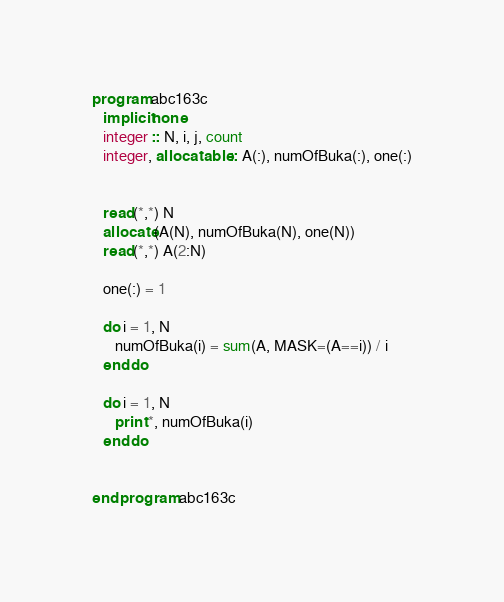Convert code to text. <code><loc_0><loc_0><loc_500><loc_500><_FORTRAN_>program abc163c
   implicit none
   integer :: N, i, j, count
   integer, allocatable :: A(:), numOfBuka(:), one(:)


   read(*,*) N
   allocate(A(N), numOfBuka(N), one(N))
   read(*,*) A(2:N)

   one(:) = 1

   do i = 1, N
      numOfBuka(i) = sum(A, MASK=(A==i)) / i
   end do

   do i = 1, N
      print *, numOfBuka(i)
   end do


end program abc163c
</code> 